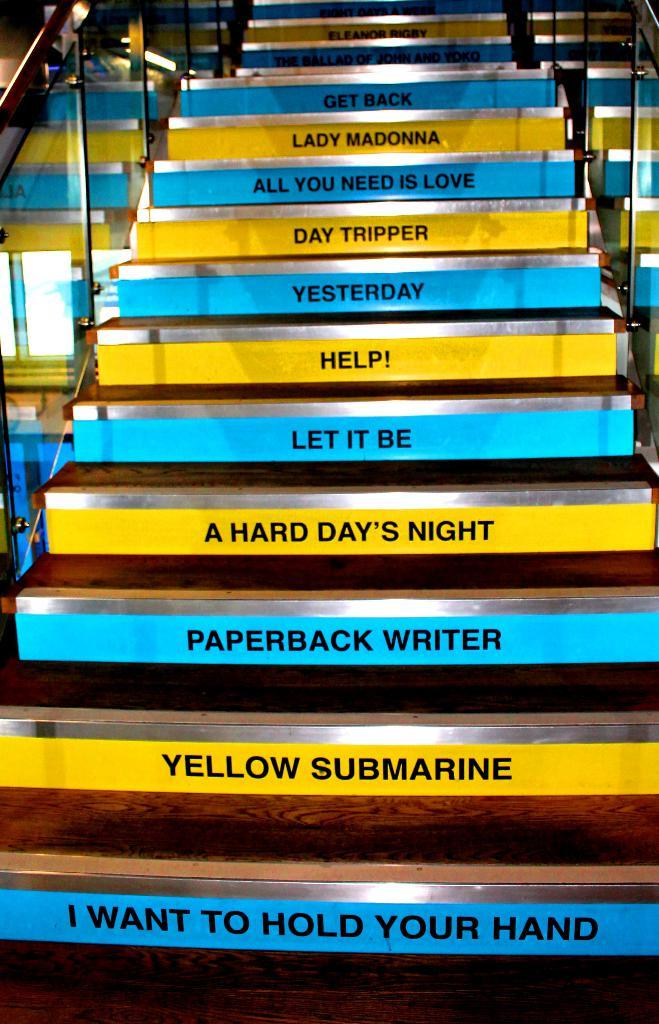<image>
Give a short and clear explanation of the subsequent image. Different Beatle song titles decorate the steps of a wood, glass and chrome staircase. 